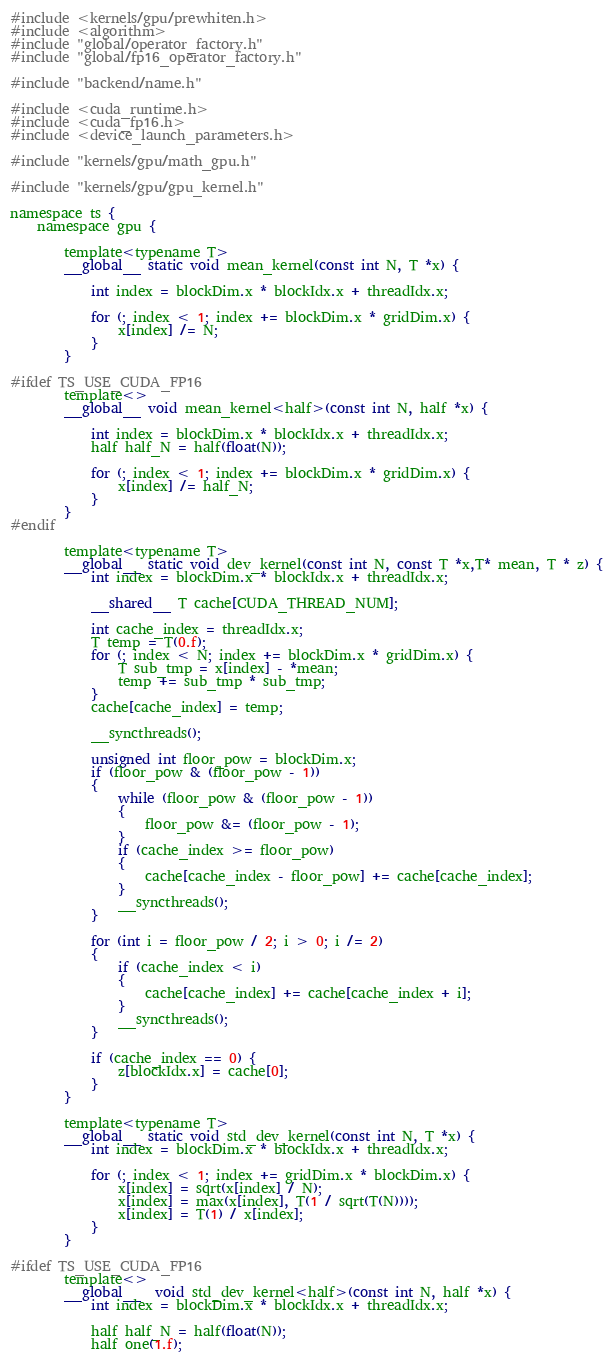Convert code to text. <code><loc_0><loc_0><loc_500><loc_500><_Cuda_>#include <kernels/gpu/prewhiten.h>
#include <algorithm>
#include "global/operator_factory.h"
#include "global/fp16_operator_factory.h"

#include "backend/name.h"

#include <cuda_runtime.h>
#include <cuda_fp16.h>
#include <device_launch_parameters.h>

#include "kernels/gpu/math_gpu.h"

#include "kernels/gpu/gpu_kernel.h"

namespace ts {
    namespace gpu {

        template<typename T>
        __global__ static void mean_kernel(const int N, T *x) {

            int index = blockDim.x * blockIdx.x + threadIdx.x;

            for (; index < 1; index += blockDim.x * gridDim.x) {
                x[index] /= N;
            }
        }

#ifdef TS_USE_CUDA_FP16
        template<>
        __global__ void mean_kernel<half>(const int N, half *x) {

            int index = blockDim.x * blockIdx.x + threadIdx.x;
            half half_N = half(float(N));

            for (; index < 1; index += blockDim.x * gridDim.x) {
                x[index] /= half_N;
            }
        }
#endif

        template<typename T>
        __global__ static void dev_kernel(const int N, const T *x,T* mean, T * z) {
            int index = blockDim.x * blockIdx.x + threadIdx.x;

            __shared__ T cache[CUDA_THREAD_NUM];

            int cache_index = threadIdx.x;
            T temp = T(0.f);
            for (; index < N; index += blockDim.x * gridDim.x) {
                T sub_tmp = x[index] - *mean;
                temp += sub_tmp * sub_tmp;
            }
            cache[cache_index] = temp;

            __syncthreads();

            unsigned int floor_pow = blockDim.x;
            if (floor_pow & (floor_pow - 1))
            {
                while (floor_pow & (floor_pow - 1))
                {
                    floor_pow &= (floor_pow - 1);
                }
                if (cache_index >= floor_pow)
                {
                    cache[cache_index - floor_pow] += cache[cache_index];
                }
                __syncthreads();
            }

            for (int i = floor_pow / 2; i > 0; i /= 2)
            {
                if (cache_index < i)
                {
                    cache[cache_index] += cache[cache_index + i];
                }
                __syncthreads();
            }

            if (cache_index == 0) {
                z[blockIdx.x] = cache[0];
            }
        }

        template<typename T>
        __global__ static void std_dev_kernel(const int N, T *x) {
            int index = blockDim.x * blockIdx.x + threadIdx.x;

            for (; index < 1; index += gridDim.x * blockDim.x) {
                x[index] = sqrt(x[index] / N);
                x[index] = max(x[index], T(1 / sqrt(T(N))));
                x[index] = T(1) / x[index];
            }
        }

#ifdef TS_USE_CUDA_FP16
        template<>
        __global__  void std_dev_kernel<half>(const int N, half *x) {
            int index = blockDim.x * blockIdx.x + threadIdx.x;

            half half_N = half(float(N));
            half one(1.f);
</code> 